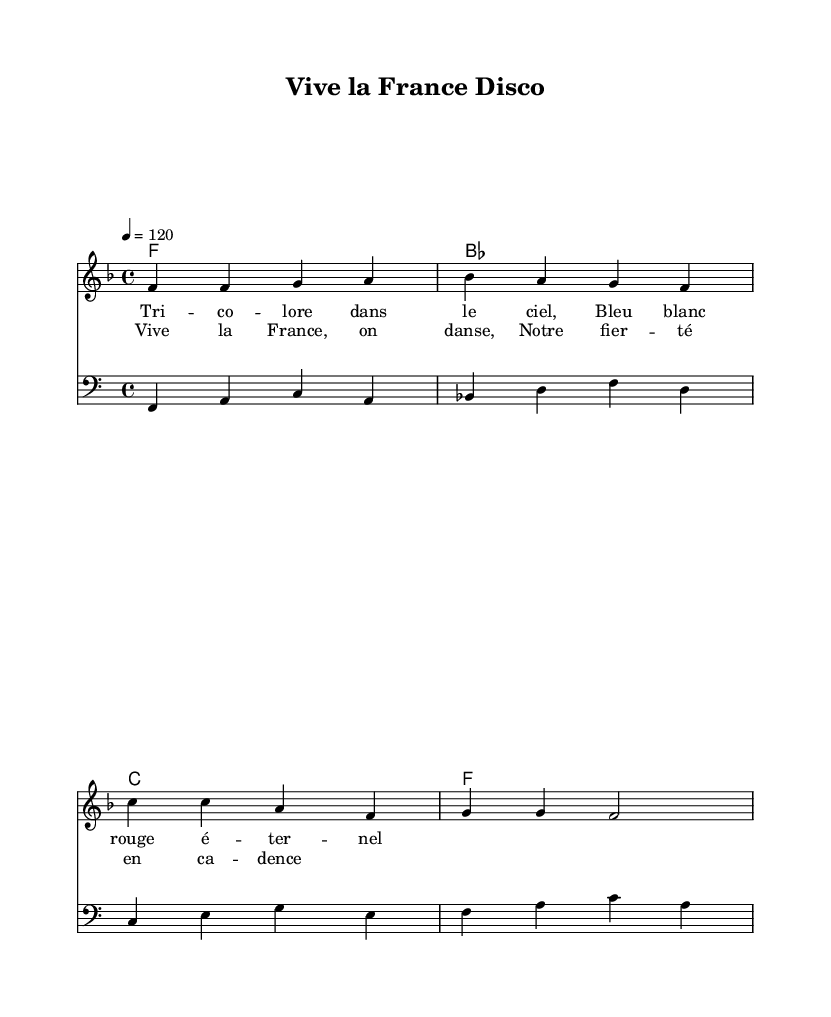What is the key signature of this music? The key signature is F major, indicated by one flat (B flat) in the key signature area.
Answer: F major What is the time signature of this music? The time signature is 4/4, shown at the beginning of the score, indicating four beats per measure.
Answer: 4/4 What is the tempo marking in this piece? The tempo marking states "4 = 120," meaning there are 120 beats per minute, and each quarter note receives one beat.
Answer: 120 What are the lyrics of the chorus? The lyrics for the chorus are "Vive la France, on danse, Notre fierté en cadence," which is placed after the first verse in the sheet music.
Answer: Vive la France, on danse, Notre fierté en cadence How many measures are in the melody section? The melody section consists of four measures, as indicated by the grouping of notes and the bar lines separating them.
Answer: 4 measures What is the bassline's clef? The bassline uses the bass clef, which is denoted at the beginning of the bassline staff, typically used for lower-pitched instruments.
Answer: Bass clef What style of music is this piece classified as? This piece is classified as Disco, specifically a classic French disco hit that celebrates national pride, as inferred from its upbeat rhythm and lyrics.
Answer: Disco 